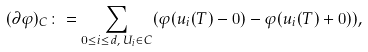Convert formula to latex. <formula><loc_0><loc_0><loc_500><loc_500>( \partial \varphi ) _ { C } \colon = \sum _ { 0 \leq i \leq d , \, U _ { i } \in C } ( \varphi ( u _ { i } ( T ) - 0 ) - \varphi ( u _ { i } ( T ) + 0 ) ) ,</formula> 